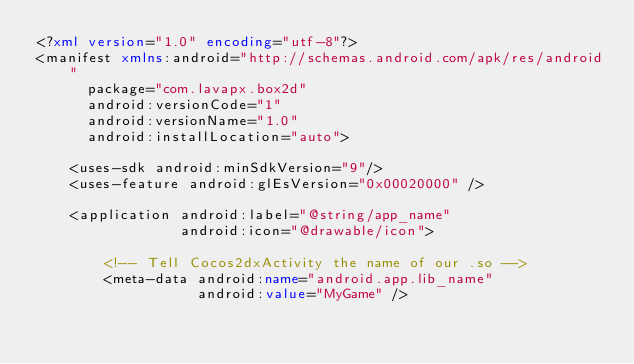<code> <loc_0><loc_0><loc_500><loc_500><_XML_><?xml version="1.0" encoding="utf-8"?>
<manifest xmlns:android="http://schemas.android.com/apk/res/android"
      package="com.lavapx.box2d"
      android:versionCode="1"
      android:versionName="1.0"
      android:installLocation="auto">

    <uses-sdk android:minSdkVersion="9"/>
    <uses-feature android:glEsVersion="0x00020000" />

    <application android:label="@string/app_name"
                 android:icon="@drawable/icon">
					 
        <!-- Tell Cocos2dxActivity the name of our .so -->
        <meta-data android:name="android.app.lib_name"
                   android:value="MyGame" />
</code> 